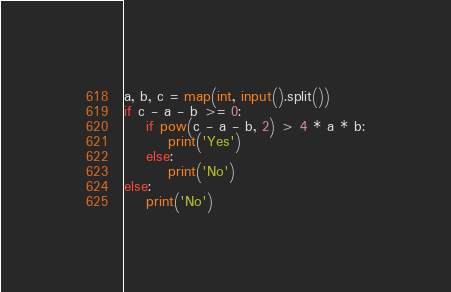Convert code to text. <code><loc_0><loc_0><loc_500><loc_500><_Python_>a, b, c = map(int, input().split())
if c - a - b >= 0:
    if pow(c - a - b, 2) > 4 * a * b:
        print('Yes')
    else:
        print('No')
else:
    print('No')</code> 